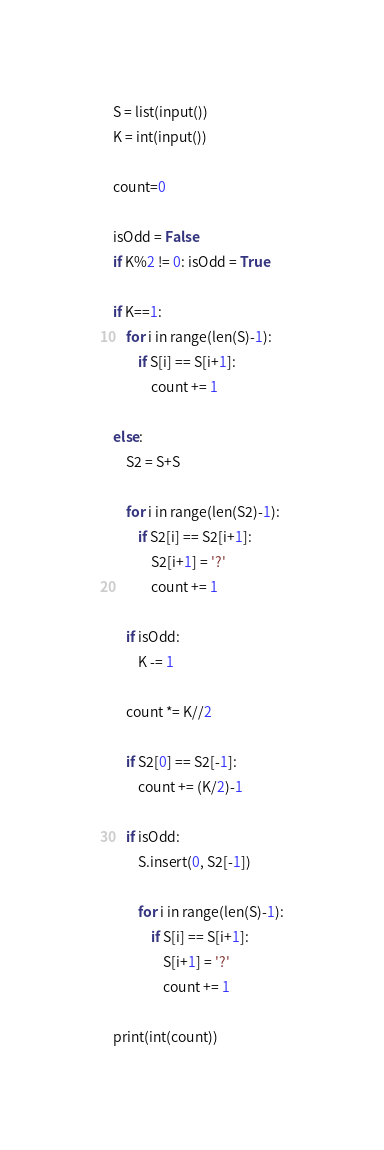Convert code to text. <code><loc_0><loc_0><loc_500><loc_500><_Python_>S = list(input())
K = int(input())

count=0

isOdd = False
if K%2 != 0: isOdd = True

if K==1:
	for i in range(len(S)-1):
		if S[i] == S[i+1]:
			count += 1

else:
	S2 = S+S

	for i in range(len(S2)-1):
		if S2[i] == S2[i+1]:
			S2[i+1] = '?'
			count += 1
	
	if isOdd:
		K -= 1
	
	count *= K//2

	if S2[0] == S2[-1]:
		count += (K/2)-1

	if isOdd:
		S.insert(0, S2[-1])

		for i in range(len(S)-1):
			if S[i] == S[i+1]:
				S[i+1] = '?'
				count += 1

print(int(count))</code> 